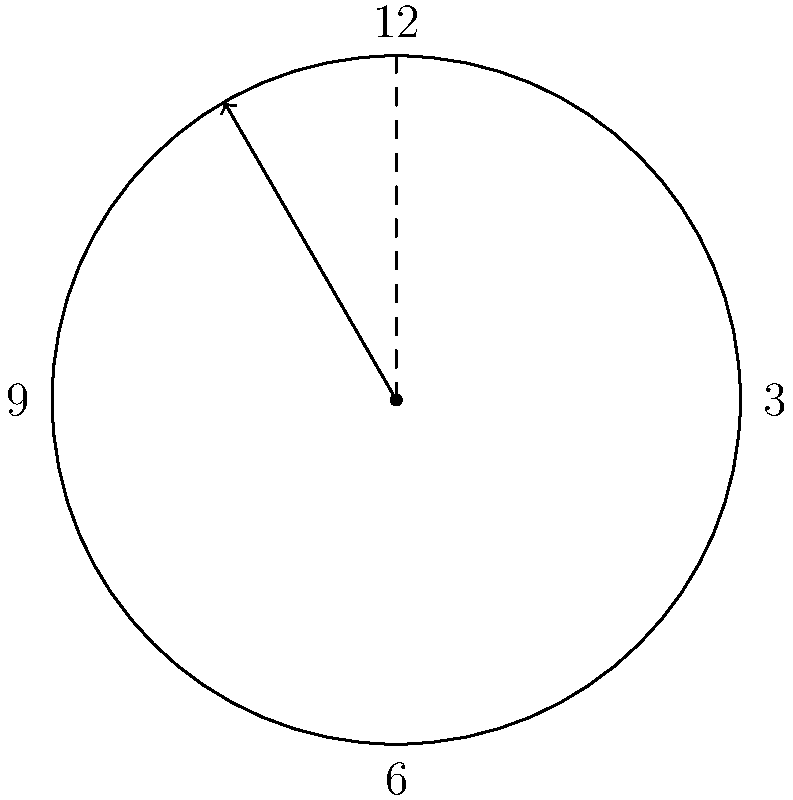As the CEO of a luxury watch brand, you're showcasing a new model to potential Middle Eastern investors. The watch's hour hand is positioned as shown in the diagram. If the watch displays exactly 4:00, what is the angle (in degrees) between the hour hand and the 12 o'clock position? To solve this problem, we need to understand how the hour hand moves:

1. In 12 hours, the hour hand makes a complete 360° rotation.
2. Therefore, in 1 hour, the hour hand rotates by 360° ÷ 12 = 30°.

At 4:00, we can calculate the angle as follows:

1. From 12 to 4, there are 4 hours.
2. Angle rotated = 4 × 30° = 120°

To verify:
- Using the formula: Angle = (Hour × 30°) + (Minute × 0.5°)
- At 4:00, Hour = 4, Minute = 0
- Angle = (4 × 30°) + (0 × 0.5°) = 120° + 0° = 120°

The diagram confirms this, as the hour hand is positioned at 120° from the 12 o'clock position (which is equivalent to 2π/3 radians, as shown in the Asymptote code).
Answer: 120° 